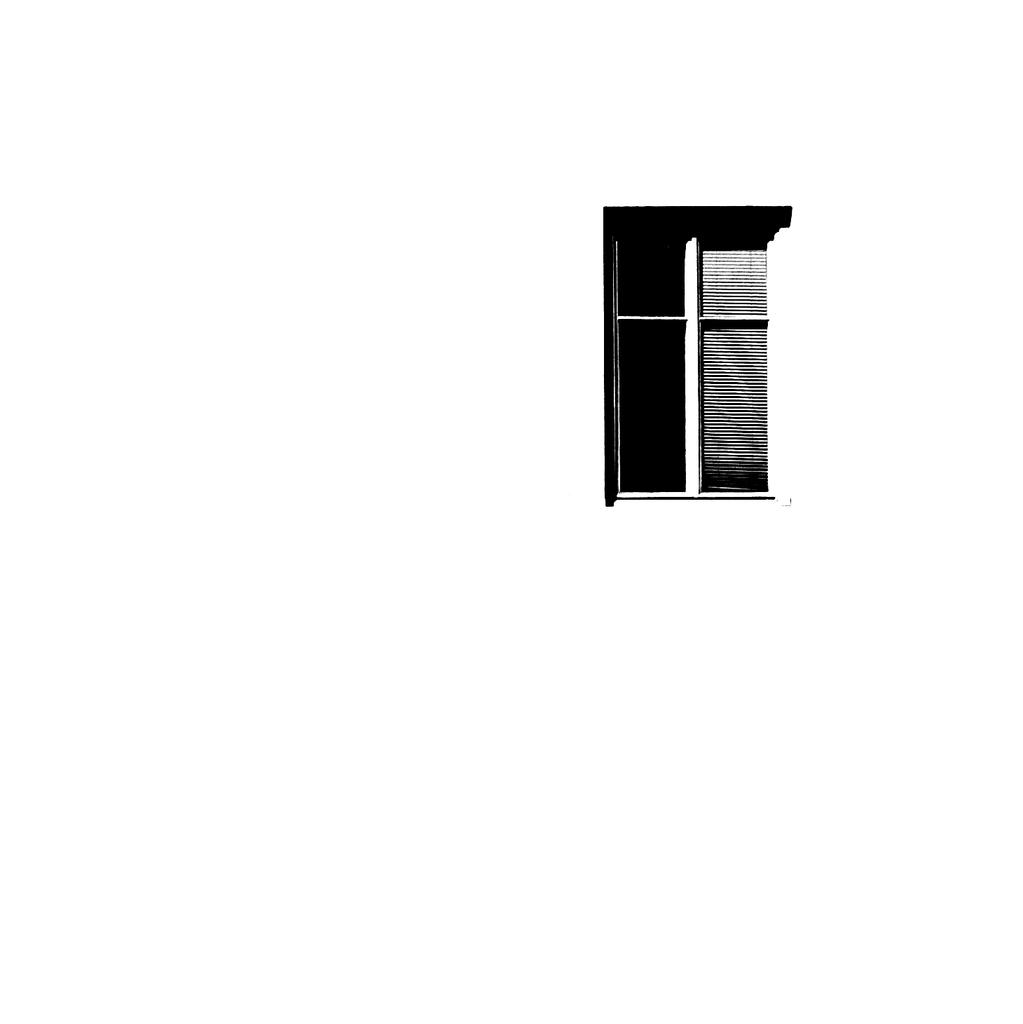What is the main feature of the image? There is a black and white window-like structure in the image. Can you describe the appearance of the structure? The structure appears to be black and white and has a window-like shape. What type of picture is being displayed on the drum in the image? There is no drum present in the image, and therefore no picture can be displayed on it. 